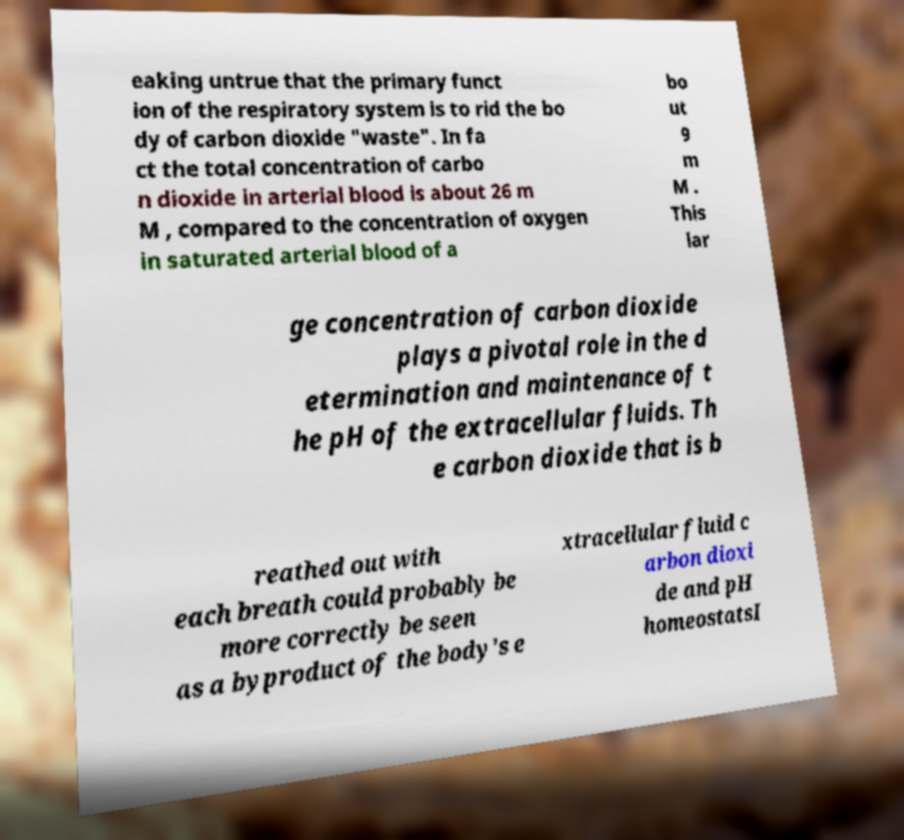Can you read and provide the text displayed in the image?This photo seems to have some interesting text. Can you extract and type it out for me? eaking untrue that the primary funct ion of the respiratory system is to rid the bo dy of carbon dioxide "waste". In fa ct the total concentration of carbo n dioxide in arterial blood is about 26 m M , compared to the concentration of oxygen in saturated arterial blood of a bo ut 9 m M . This lar ge concentration of carbon dioxide plays a pivotal role in the d etermination and maintenance of t he pH of the extracellular fluids. Th e carbon dioxide that is b reathed out with each breath could probably be more correctly be seen as a byproduct of the body's e xtracellular fluid c arbon dioxi de and pH homeostatsI 